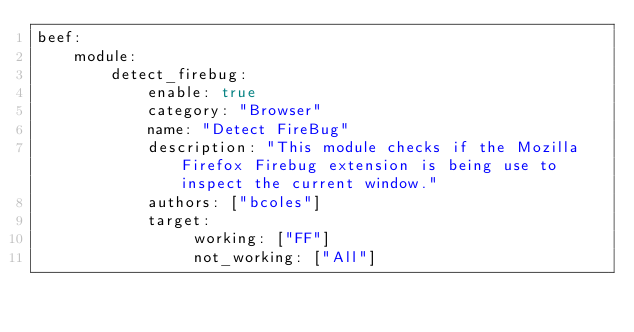Convert code to text. <code><loc_0><loc_0><loc_500><loc_500><_YAML_>beef:
    module:
        detect_firebug:
            enable: true
            category: "Browser"
            name: "Detect FireBug"
            description: "This module checks if the Mozilla Firefox Firebug extension is being use to inspect the current window."
            authors: ["bcoles"]
            target:
                 working: ["FF"]
                 not_working: ["All"]
</code> 